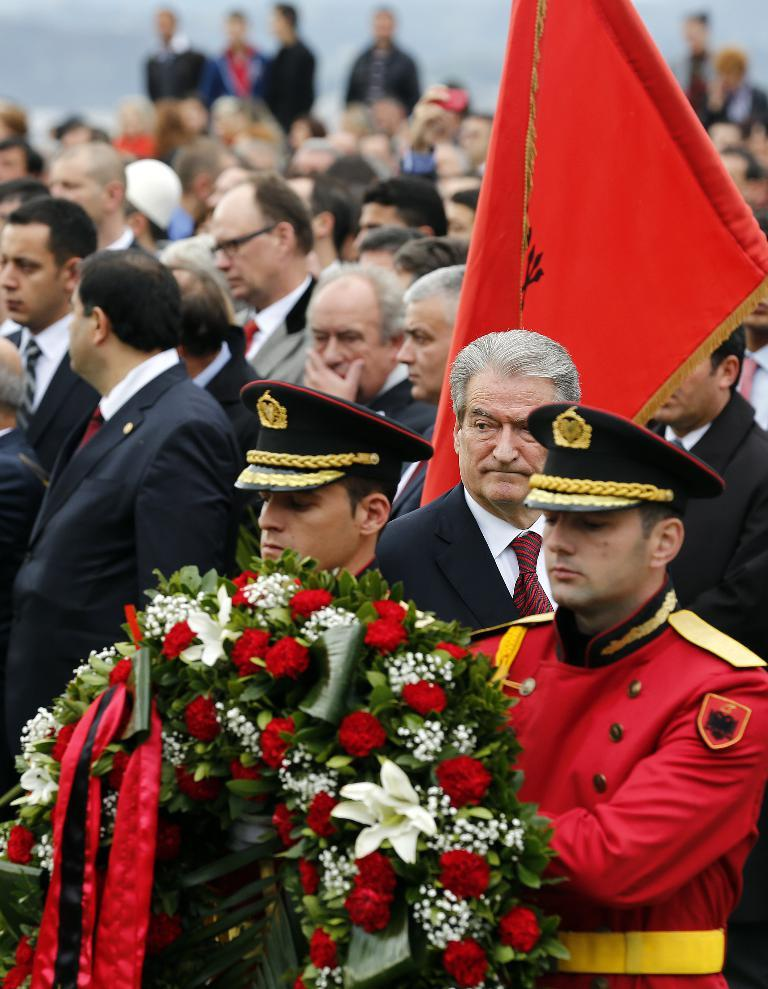Who or what can be seen in the image? There are people in the image. What object is present in the image that represents a group or nation? There is a flag in the image. What type of decorative item can be seen in the image? There is a flower bouquet in the image. How would you describe the background of the image? The background of the image has a blurred view. What type of creature is depicted in the image? There is no creature depicted in the image; it features people, a flag, and a flower bouquet. What historical event is being commemorated in the image? The image does not depict any specific historical event; it simply shows people, a flag, and a flower bouquet. 